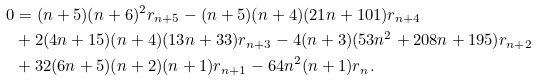<formula> <loc_0><loc_0><loc_500><loc_500>0 & = ( n + 5 ) ( n + 6 ) ^ { 2 } r _ { n + 5 } - ( n + 5 ) ( n + 4 ) ( 2 1 n + 1 0 1 ) r _ { n + 4 } \\ & + 2 ( 4 n + 1 5 ) ( n + 4 ) ( 1 3 n + 3 3 ) r _ { n + 3 } - 4 ( n + 3 ) ( 5 3 n ^ { 2 } + 2 0 8 n + 1 9 5 ) r _ { n + 2 } \\ & + 3 2 ( 6 n + 5 ) ( n + 2 ) ( n + 1 ) r _ { n + 1 } - 6 4 n ^ { 2 } ( n + 1 ) r _ { n } .</formula> 